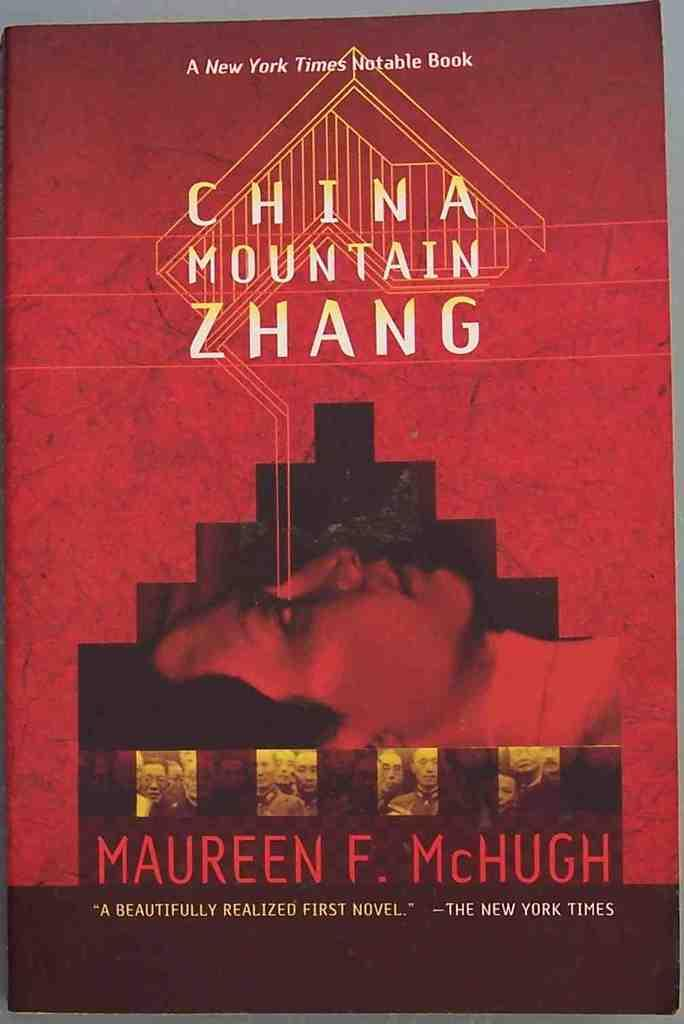<image>
Describe the image concisely. A copy of the book china mountain zhang by maureen f mchugh. 